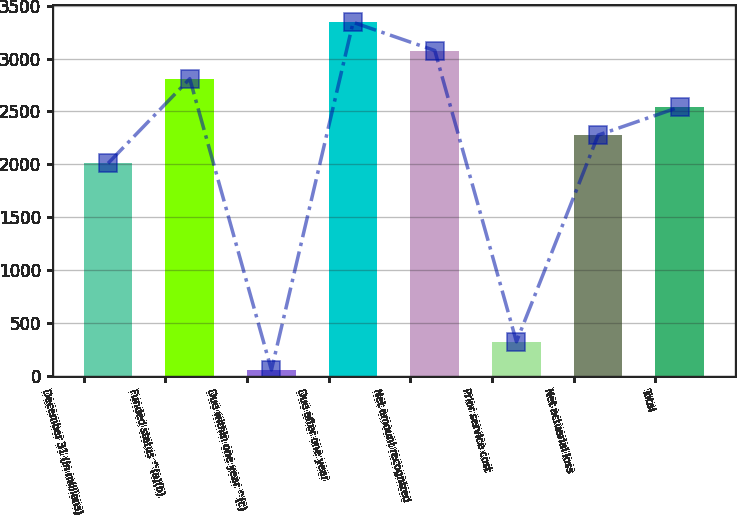<chart> <loc_0><loc_0><loc_500><loc_500><bar_chart><fcel>December 31 (In millions)<fcel>Funded status ^(a)(b)<fcel>Due within one year ^(c)<fcel>Due after one year<fcel>Net amount recognized<fcel>Prior service cost<fcel>Net actuarial loss<fcel>Total<nl><fcel>2009<fcel>2809.4<fcel>54<fcel>3343<fcel>3076.2<fcel>320.8<fcel>2275.8<fcel>2542.6<nl></chart> 